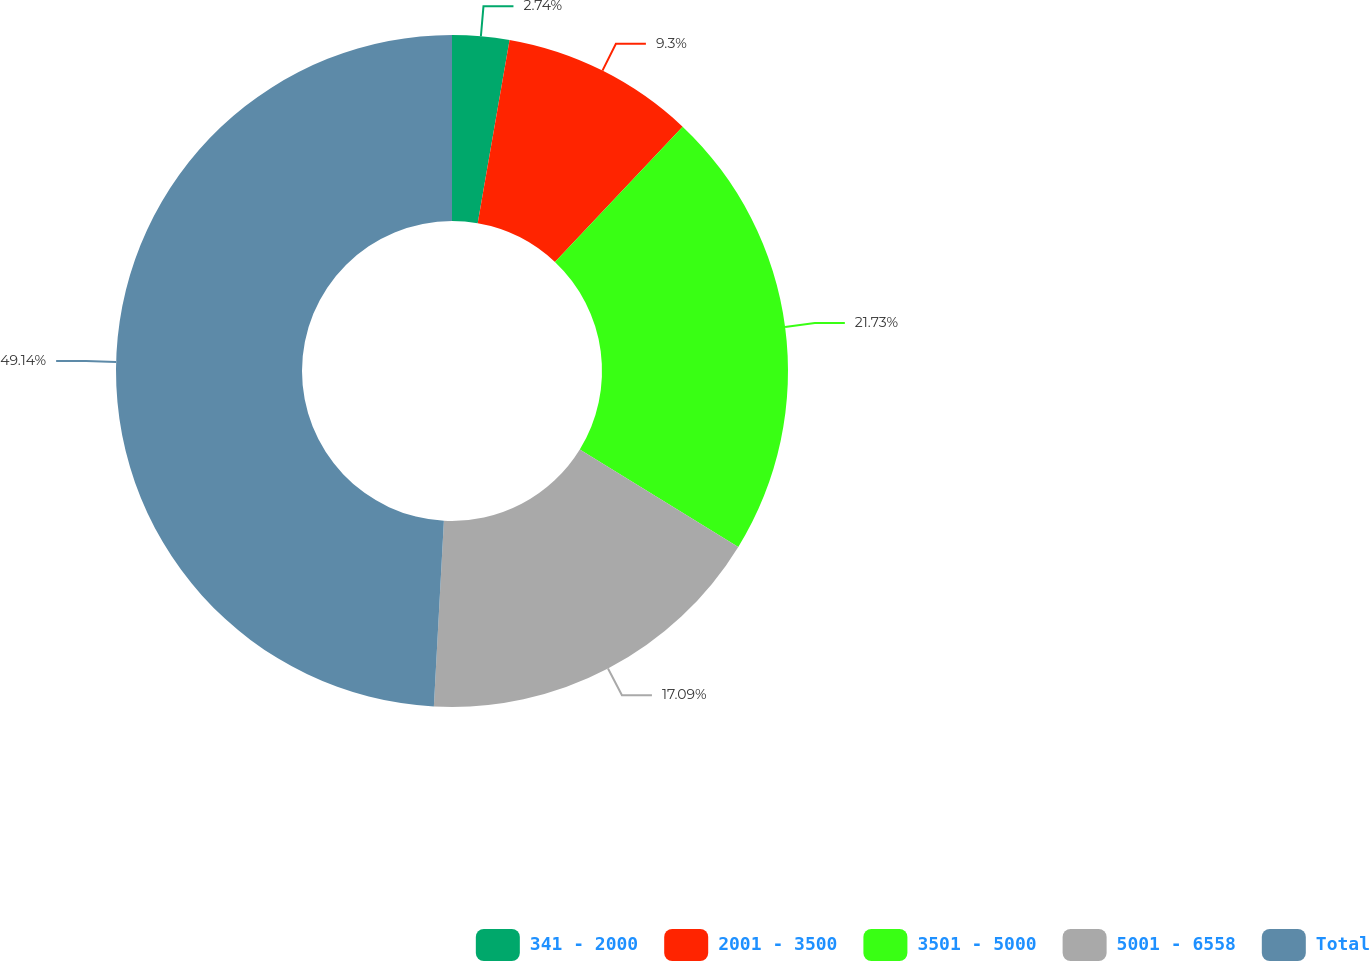<chart> <loc_0><loc_0><loc_500><loc_500><pie_chart><fcel>341 - 2000<fcel>2001 - 3500<fcel>3501 - 5000<fcel>5001 - 6558<fcel>Total<nl><fcel>2.74%<fcel>9.3%<fcel>21.73%<fcel>17.09%<fcel>49.14%<nl></chart> 